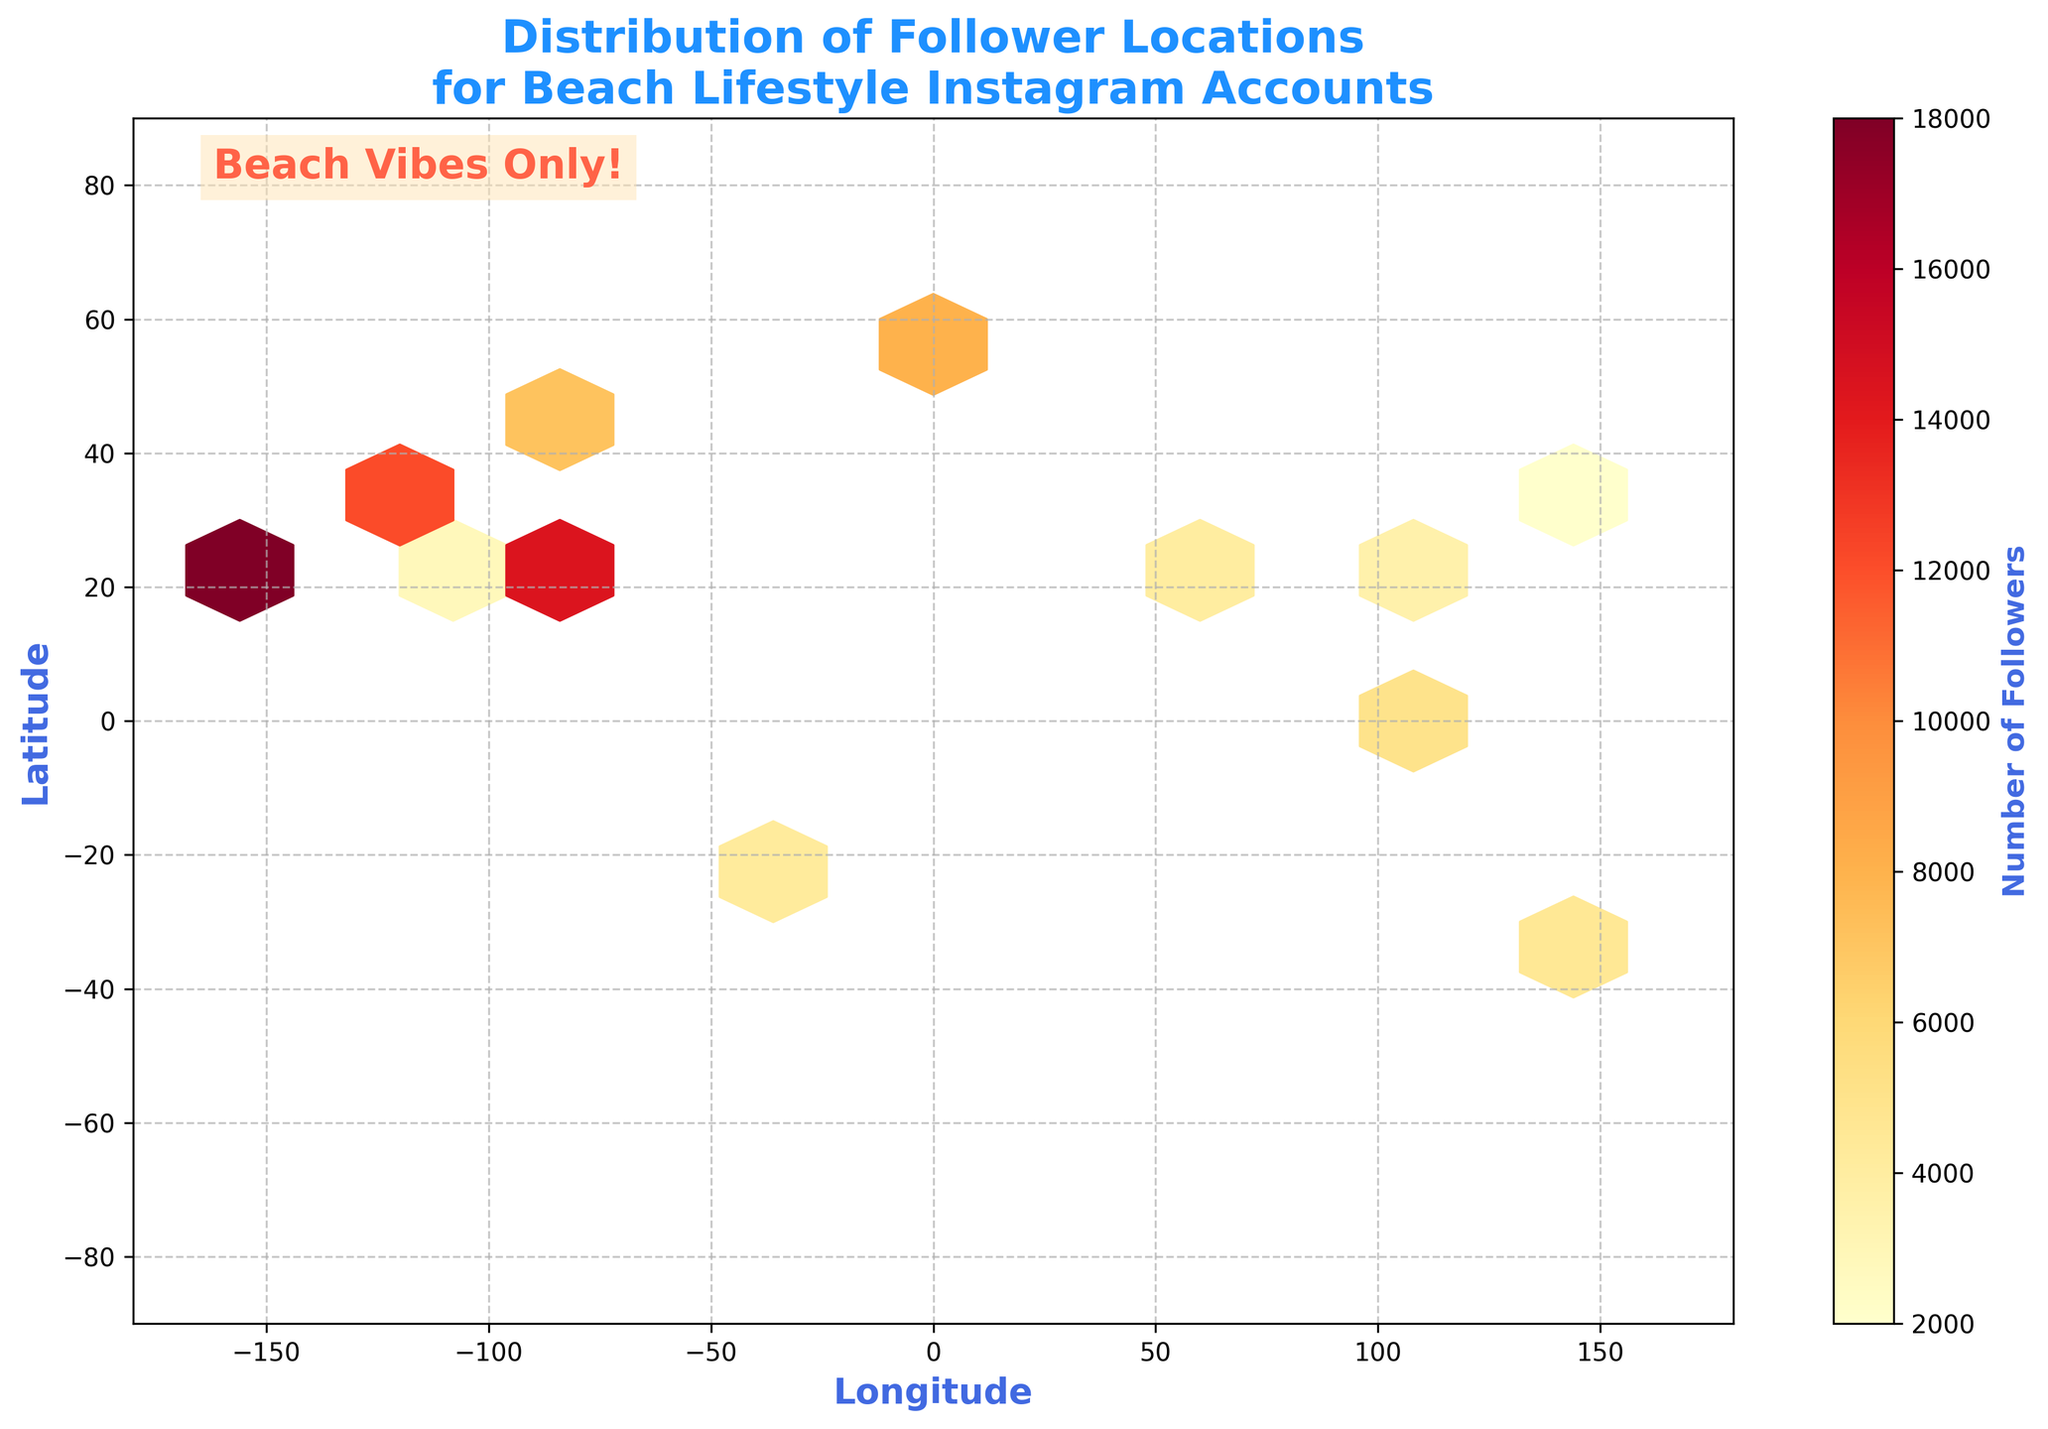What is the title of the plot? The title is prominently displayed at the top of the plot, usually in a larger and bolded font.
Answer: Distribution of Follower Locations for Beach Lifestyle Instagram Accounts What does the color bar represent? The color bar indicates the number of followers; the color depth corresponds to different follower counts, usually signified by warmer colors for higher values.
Answer: Number of Followers What grid size is used in the hexbin plot? The hexbin plot grid size is often set to ensure the hexagons aren’t too small or too large; it strikes a balance for optimal visual comprehension based on the code, the grid size used is 15.
Answer: 15 What does the text "Beach Vibes Only!" refer to on the plot? This text appears as a type of annotation or decoration within the plot, reinforcing the theme or focus, usually in a fun and catchy tone.
Answer: Annotation text to reinforce the beach lifestyle theme Which region has the highest density of followers? By examining the area with the darkest or most saturated hexagons, you can determine the region with the highest density of followers. In this case, the region around Miami (Longitude: -80) appears to have the highest density.
Answer: Around Miami Are there any follower locations near the equator? By looking at the latitudes near 0° on the y-axis, we can see if any hexagons are colored, indicating follower locations. Yes, categories like Singapore (Latitude: 1.3) show points near the equator.
Answer: Yes How many followers are near Los Angeles (Latitude: 34, Longitude: -118)? By locating the hexagon nearest to these coordinates and reading the color bar, we estimate the number of followers associated with Los Angeles, which shows hexagons with about 15,000 to 20,000 followers in the specified range.
Answer: Around 15,000 Compare the follower count near Tokyo and Mexico City. Which is higher? To compare, identify hexagons near Tokyo (Latitude: 35.7, Longitude: 139.65) and Mexico City (Latitude: 19.43, Longitude: -99.13) and compare their shade intensity per the color bar, with Tokyo's hexagon indicating fewer followers.
Answer: Mexico City Which cities have higher follower counts: New York or Sydney? We identify percentages and shades around New York (Latitude: 40.71, Longitude: -74.01) and Sydney (Latitude: -33.87, Longitude: 151.21). Generally, New York's region appears to have darker shades, indicating higher followers.
Answer: New York Is there any data representation off the coast of the African continent? Examine the hexagons within the proximity of the African region, around longitude 10° to 40°, and latitude -30° to 30°. No significant hexagon shades are observable to suggest followers’ data presence.
Answer: No 